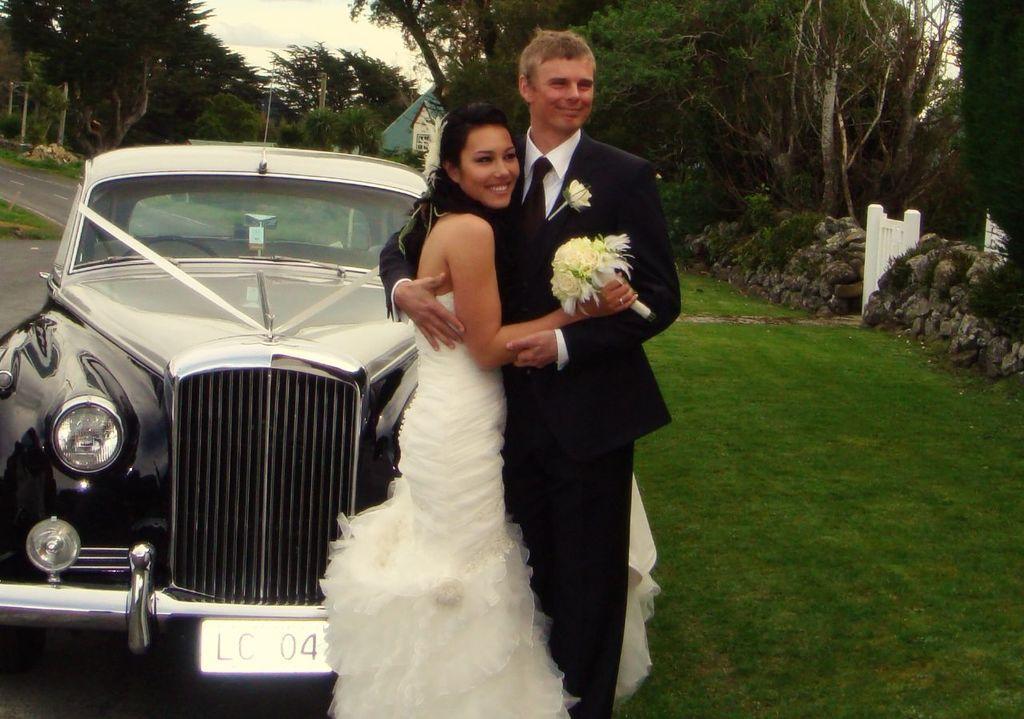In one or two sentences, can you explain what this image depicts? In the foreground of this picture, there is a couple standing on the grass hugging each other in front of a car. In the background, there are plants, grass, gate, trees, house and the sky. 